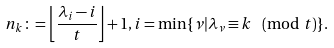Convert formula to latex. <formula><loc_0><loc_0><loc_500><loc_500>n _ { k } \colon = \left \lfloor \frac { \lambda _ { i } - i } { t } \right \rfloor + 1 , i = \min \{ \nu | \lambda _ { \nu } \equiv k \pmod { t } \} .</formula> 